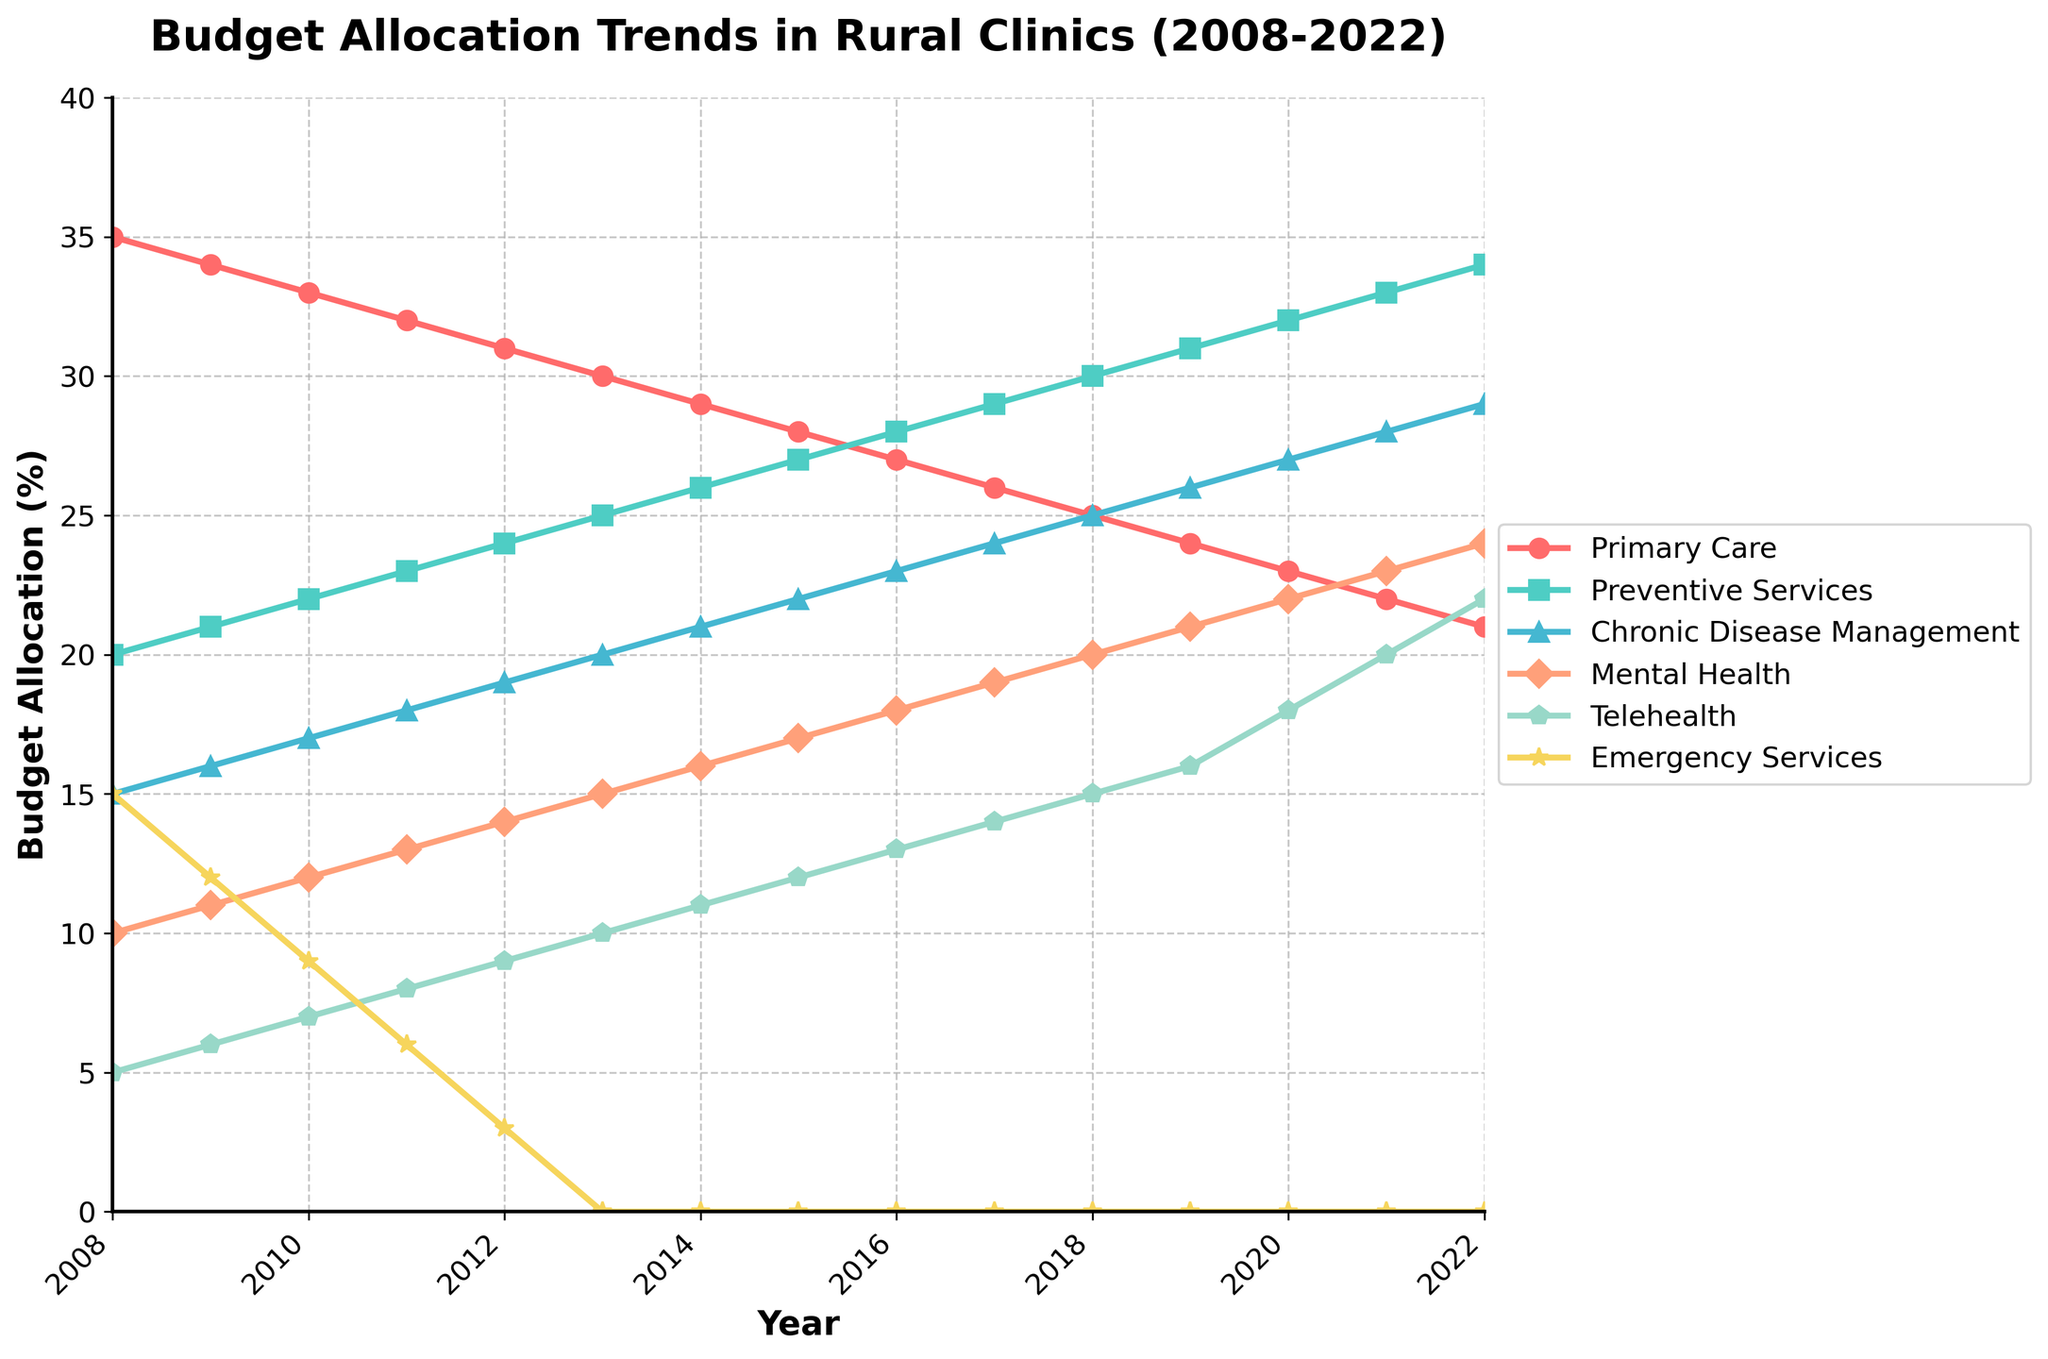What was the budget allocation for Primary Care in 2008? To find the budget allocation for Primary Care in 2008, locate the point on the Primary Care line that aligns with the year 2008 on the x-axis. The value is directly indicated on the y-axis as 35%.
Answer: 35% How did the budget allocation for Mental Health change from 2010 to 2020? To determine the change in budget allocation for Mental Health from 2010 to 2020, locate the values for Mental Health in 2010 and 2020. The allocation in 2010 was 12%, and it increased to 22% in 2020. The change is the difference between these values, 22% - 12% = 10%.
Answer: Increased by 10% Which year shows the highest budget allocation for Preventive Services? To find the highest budget allocation for Preventive Services, trace the Preventive Services line across the years and identify the peak value. The highest point on the Preventive Services line occurs in 2022 with a value of 34%.
Answer: 2022 Did the budget allocation for Emergency Services reach zero, and if so, in which year? To determine if the budget allocation for Emergency Services reached zero, follow the Emergency Services line and look for a point where it intersects the x-axis. The budget reached zero in 2013 and remained zero onwards.
Answer: 2013 What was the cumulative budget allocation for Chronic Disease Management and Mental Health in 2015? To find the cumulative budget allocation for Chronic Disease Management and Mental Health in 2015, add the values for both programs in that year: 22% (Chronic Disease Management) + 17% (Mental Health) = 39%.
Answer: 39% Compare the budget allocation for Telehealth and Primary Care in 2022. Which program received more funding? To compare the budget allocation for Telehealth and Primary Care in 2022, locate the respective values for each program in that year. Telehealth received 22%, while Primary Care received 21%. Telehealth received more funding.
Answer: Telehealth What is the average budget allocation for Preventive Services over the years displayed? To calculate the average budget allocation for Preventive Services, sum the values from each year and divide by the number of years (15 years). The sum is 20+21+22+23+24+25+26+27+28+29+30+31+32+33+34 = 395. The average is 395/15 = 26.33%.
Answer: 26.33% How does the trend of Primary Care's budget allocation from 2008 to 2022 differ from that of Telehealth? To compare the trends, observe the Primary Care and Telehealth lines from 2008 to 2022. Primary Care shows a decreasing trend from 2008 (35%) to 2022 (21%), whereas Telehealth shows an increasing trend from 2008 (5%) to 2022 (22%).
Answer: Primary Care: decreasing, Telehealth: increasing What is the ratio of the budget allocation for Primary Care to Cheryl Disease Management in 2022? To find the ratio of the budget allocation for Primary Care to Chronic Disease Management in 2022, divide the Primary Care value by the Chronic Disease Management value: 21% / 29% ≈ 0.72.
Answer: 0.72 How many programs had a budget allocation of 30% or more in 2022? To determine how many programs had a budget allocation of 30% or more in 2022, scan the 2022 data points. Only Preventive Services (34%) and Chronic Disease Management (29%, less than 30%) approach this threshold. Therefore, only Preventive Services qualifies.
Answer: 1 